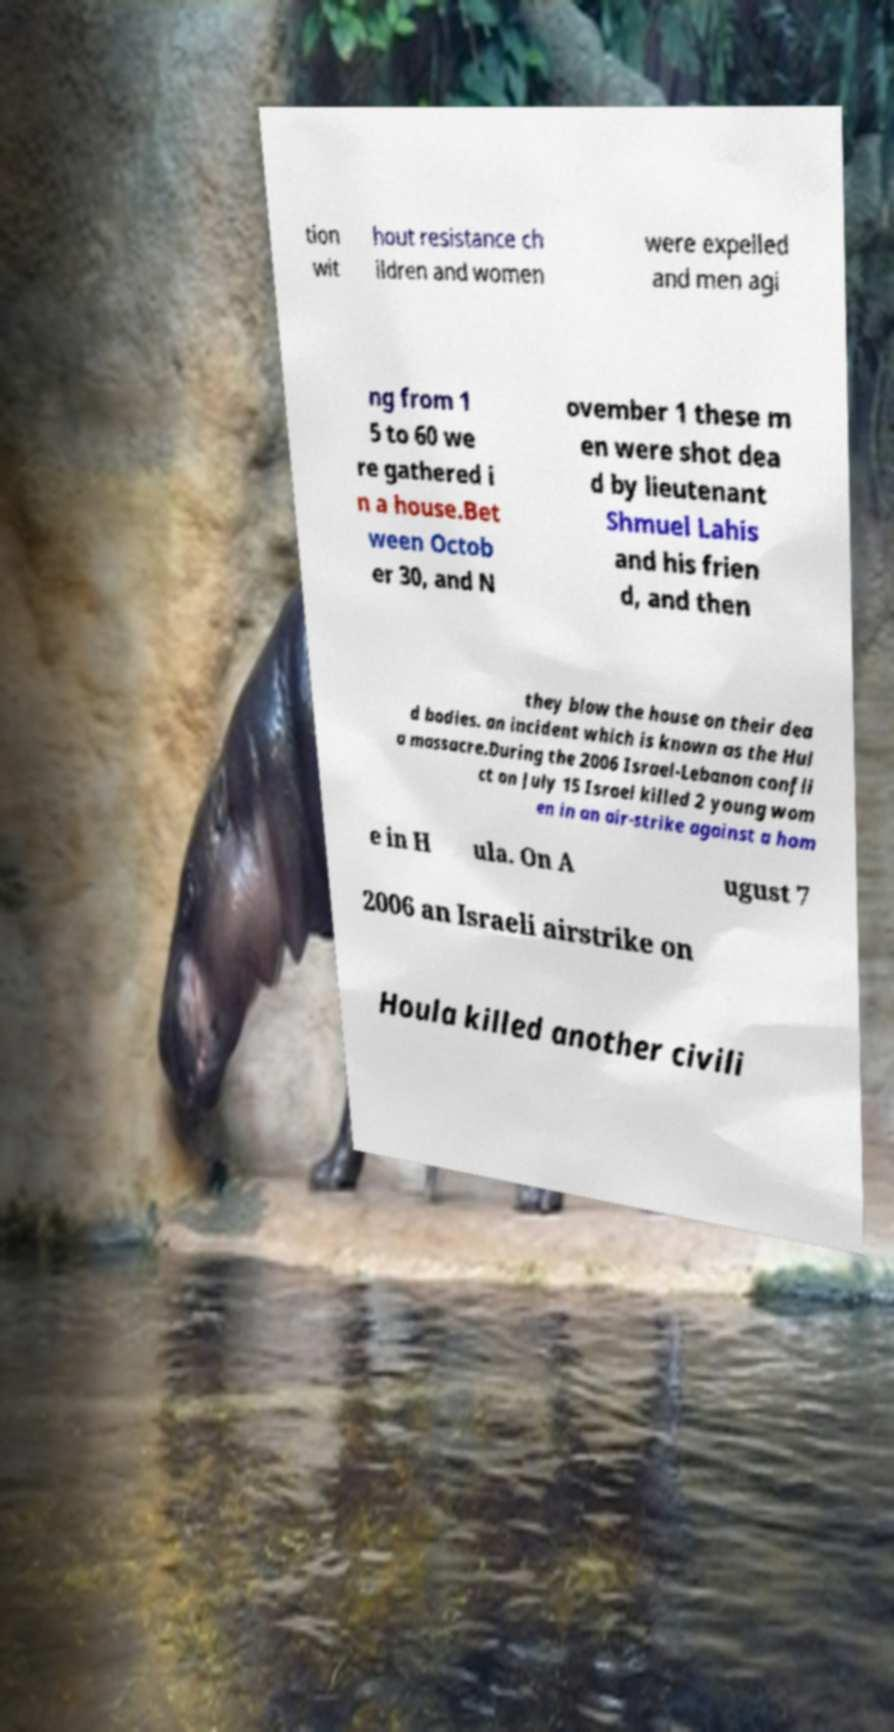What messages or text are displayed in this image? I need them in a readable, typed format. tion wit hout resistance ch ildren and women were expelled and men agi ng from 1 5 to 60 we re gathered i n a house.Bet ween Octob er 30, and N ovember 1 these m en were shot dea d by lieutenant Shmuel Lahis and his frien d, and then they blow the house on their dea d bodies. an incident which is known as the Hul a massacre.During the 2006 Israel-Lebanon confli ct on July 15 Israel killed 2 young wom en in an air-strike against a hom e in H ula. On A ugust 7 2006 an Israeli airstrike on Houla killed another civili 